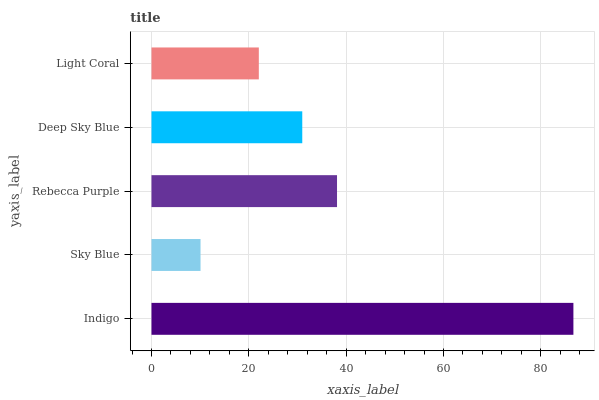Is Sky Blue the minimum?
Answer yes or no. Yes. Is Indigo the maximum?
Answer yes or no. Yes. Is Rebecca Purple the minimum?
Answer yes or no. No. Is Rebecca Purple the maximum?
Answer yes or no. No. Is Rebecca Purple greater than Sky Blue?
Answer yes or no. Yes. Is Sky Blue less than Rebecca Purple?
Answer yes or no. Yes. Is Sky Blue greater than Rebecca Purple?
Answer yes or no. No. Is Rebecca Purple less than Sky Blue?
Answer yes or no. No. Is Deep Sky Blue the high median?
Answer yes or no. Yes. Is Deep Sky Blue the low median?
Answer yes or no. Yes. Is Rebecca Purple the high median?
Answer yes or no. No. Is Sky Blue the low median?
Answer yes or no. No. 